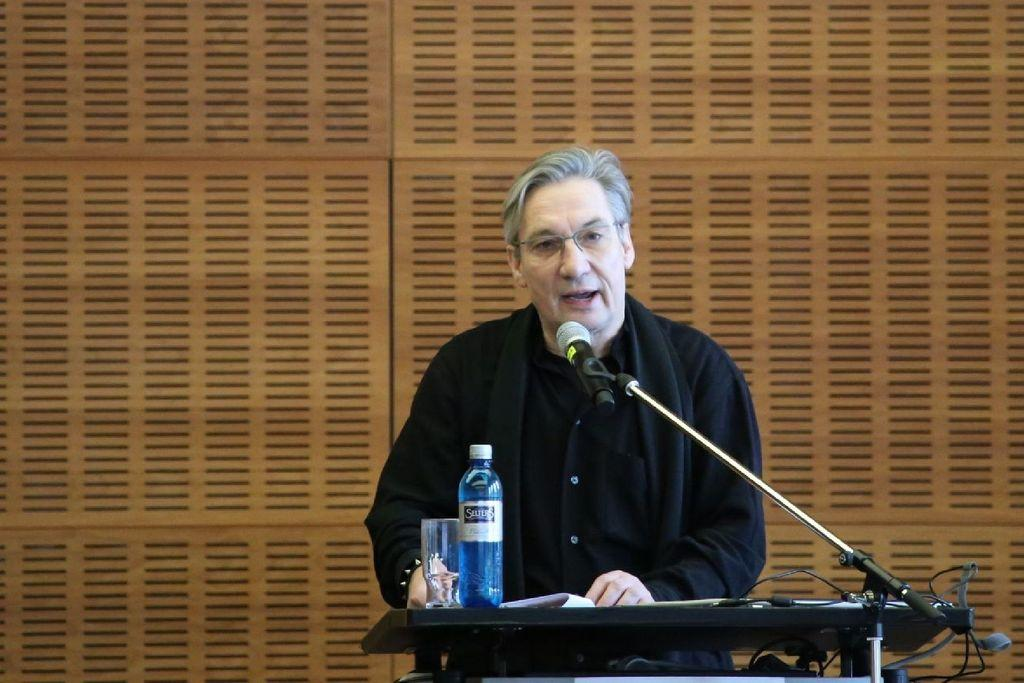What is the person in the image doing? The person is standing at a lectern in the image. What is the person holding while standing at the lectern? The person is holding a mic. What items can be seen on the lectern? Papers, a bottle, and a glass are present on the lectern. What is visible in the background of the image? There is a wall in the background of the image. What type of trick is the person performing with the fish in the image? There is no fish present in the image, and therefore no trick can be observed. 